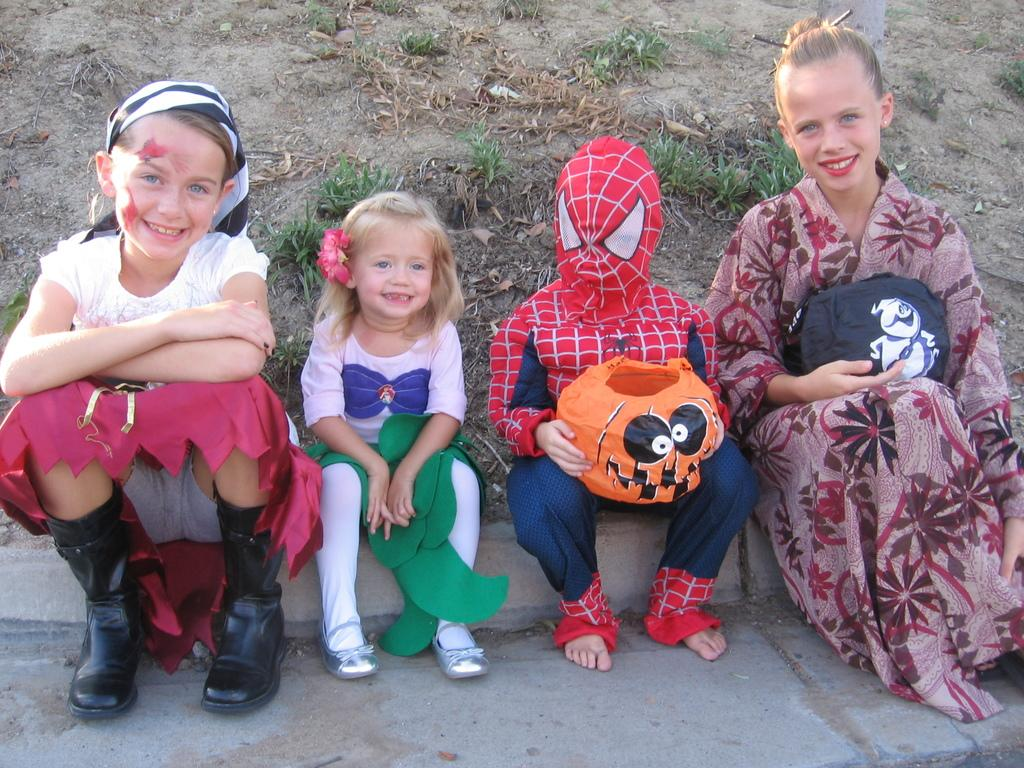How many kids are in the image? There are kids in the image, but the exact number is not specified. What are the kids wearing in the image? The kids are in different costumes in the image. Where are the kids sitting in the image? The kids are sitting on a footpath in the image. What is the background like in the image? There is muddy land with grass behind the kids in the image. What is the design of the zebra's stripes in the image? There is no zebra present in the image, so it is not possible to answer that question. 